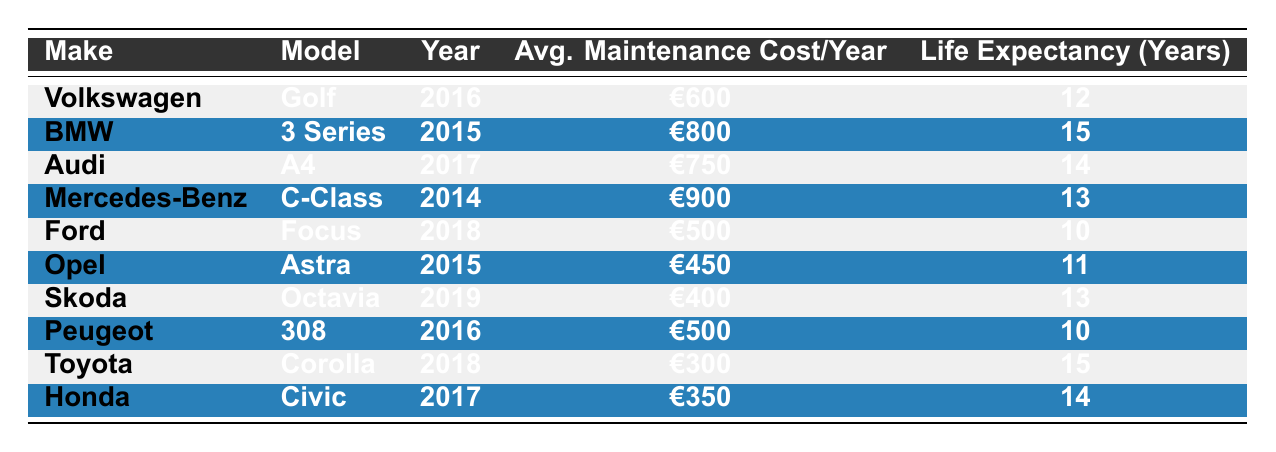What is the average maintenance cost per year for the Audi A4? The table lists the average maintenance cost per year for the Audi A4 as €750.
Answer: €750 Which car has the highest life expectancy? The BMW 3 Series has the highest life expectancy at 15 years, as observed in the life expectancy column.
Answer: BMW 3 Series What is the difference in average maintenance cost per year between the Volkswagen Golf and the Ford Focus? The average maintenance cost for the Volkswagen Golf is €600, while for the Ford Focus, it is €500. The difference is €600 - €500 = €100.
Answer: €100 Is the average maintenance cost for the Opel Astra less than €500? The average maintenance cost for the Opel Astra is €450, which is indeed less than €500.
Answer: Yes How many cars listed have a life expectancy of 13 years? The cars with a life expectancy of 13 years are the Audi A4, Mercedes-Benz C-Class, and Skoda Octavia. Therefore, there are 3 cars in total.
Answer: 3 What is the average life expectancy of all the cars listed? To find the average life expectancy, sum all life expectancy values (12 + 15 + 14 + 13 + 10 + 11 + 13 + 10 + 15 + 14 =  132) and divide by the number of cars (10). The average is 132 / 10 = 13.2 years.
Answer: 13.2 years Which brand has the lowest average maintenance cost, and what is it? The table shows that Toyota has the lowest average maintenance cost of €300 per year.
Answer: Toyota, €300 Are there any cars with a life expectancy greater than 14 years? The BMW 3 Series and the Toyota Corolla both have a life expectancy of 15 years, which is greater than 14.
Answer: Yes 